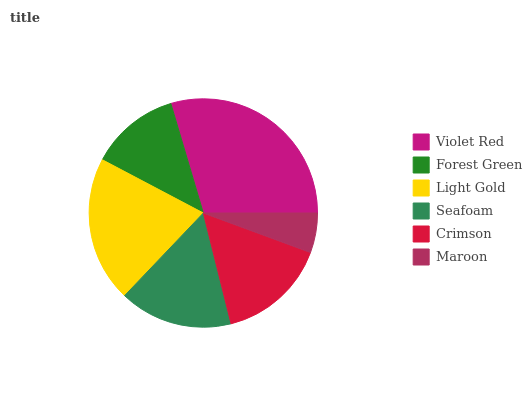Is Maroon the minimum?
Answer yes or no. Yes. Is Violet Red the maximum?
Answer yes or no. Yes. Is Forest Green the minimum?
Answer yes or no. No. Is Forest Green the maximum?
Answer yes or no. No. Is Violet Red greater than Forest Green?
Answer yes or no. Yes. Is Forest Green less than Violet Red?
Answer yes or no. Yes. Is Forest Green greater than Violet Red?
Answer yes or no. No. Is Violet Red less than Forest Green?
Answer yes or no. No. Is Seafoam the high median?
Answer yes or no. Yes. Is Crimson the low median?
Answer yes or no. Yes. Is Light Gold the high median?
Answer yes or no. No. Is Violet Red the low median?
Answer yes or no. No. 